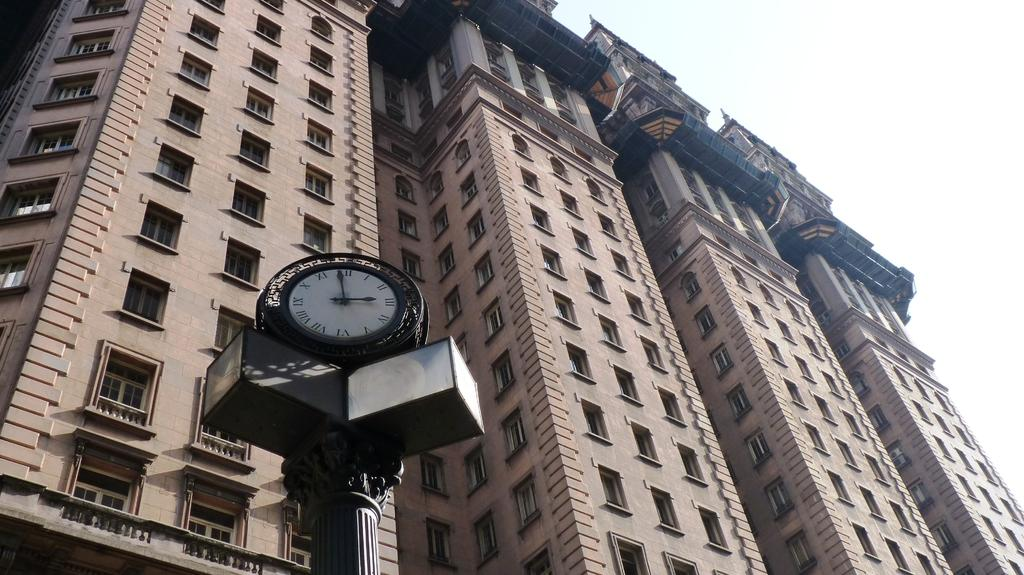<image>
Present a compact description of the photo's key features. An outdoor clock that says it's almost 3 o'clock in roman numerals. 